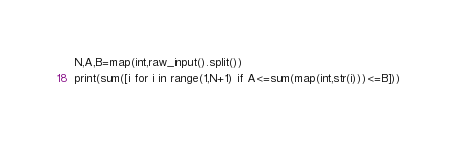<code> <loc_0><loc_0><loc_500><loc_500><_Python_>N,A,B=map(int,raw_input().split())
print(sum([i for i in range(1,N+1) if A<=sum(map(int,str(i)))<=B]))</code> 